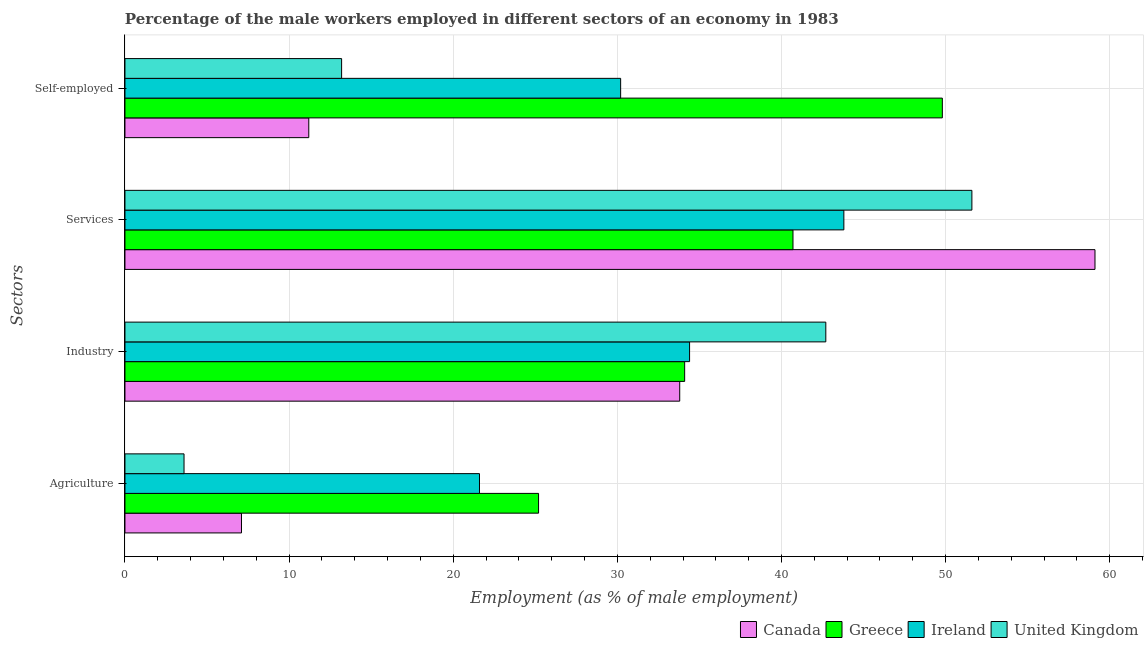How many different coloured bars are there?
Your answer should be compact. 4. Are the number of bars on each tick of the Y-axis equal?
Provide a short and direct response. Yes. How many bars are there on the 4th tick from the top?
Offer a terse response. 4. What is the label of the 4th group of bars from the top?
Your answer should be compact. Agriculture. What is the percentage of self employed male workers in United Kingdom?
Offer a very short reply. 13.2. Across all countries, what is the maximum percentage of male workers in agriculture?
Offer a very short reply. 25.2. Across all countries, what is the minimum percentage of male workers in industry?
Your response must be concise. 33.8. In which country was the percentage of male workers in services minimum?
Make the answer very short. Greece. What is the total percentage of male workers in services in the graph?
Ensure brevity in your answer.  195.2. What is the difference between the percentage of male workers in industry in Canada and that in Greece?
Your answer should be very brief. -0.3. What is the difference between the percentage of male workers in industry in Canada and the percentage of self employed male workers in Greece?
Make the answer very short. -16. What is the average percentage of self employed male workers per country?
Provide a short and direct response. 26.1. What is the difference between the percentage of male workers in services and percentage of self employed male workers in Ireland?
Make the answer very short. 13.6. In how many countries, is the percentage of male workers in industry greater than 10 %?
Make the answer very short. 4. What is the ratio of the percentage of self employed male workers in Canada to that in Greece?
Provide a succinct answer. 0.22. Is the difference between the percentage of male workers in services in Greece and United Kingdom greater than the difference between the percentage of self employed male workers in Greece and United Kingdom?
Provide a succinct answer. No. What is the difference between the highest and the lowest percentage of male workers in industry?
Your response must be concise. 8.9. What does the 2nd bar from the top in Self-employed represents?
Your answer should be very brief. Ireland. What does the 1st bar from the bottom in Industry represents?
Your answer should be very brief. Canada. Is it the case that in every country, the sum of the percentage of male workers in agriculture and percentage of male workers in industry is greater than the percentage of male workers in services?
Your response must be concise. No. Are all the bars in the graph horizontal?
Make the answer very short. Yes. How many countries are there in the graph?
Give a very brief answer. 4. Where does the legend appear in the graph?
Your answer should be compact. Bottom right. How many legend labels are there?
Provide a short and direct response. 4. How are the legend labels stacked?
Offer a terse response. Horizontal. What is the title of the graph?
Provide a short and direct response. Percentage of the male workers employed in different sectors of an economy in 1983. What is the label or title of the X-axis?
Offer a very short reply. Employment (as % of male employment). What is the label or title of the Y-axis?
Provide a short and direct response. Sectors. What is the Employment (as % of male employment) in Canada in Agriculture?
Keep it short and to the point. 7.1. What is the Employment (as % of male employment) of Greece in Agriculture?
Give a very brief answer. 25.2. What is the Employment (as % of male employment) in Ireland in Agriculture?
Provide a succinct answer. 21.6. What is the Employment (as % of male employment) of United Kingdom in Agriculture?
Your answer should be very brief. 3.6. What is the Employment (as % of male employment) of Canada in Industry?
Give a very brief answer. 33.8. What is the Employment (as % of male employment) in Greece in Industry?
Ensure brevity in your answer.  34.1. What is the Employment (as % of male employment) of Ireland in Industry?
Provide a short and direct response. 34.4. What is the Employment (as % of male employment) in United Kingdom in Industry?
Keep it short and to the point. 42.7. What is the Employment (as % of male employment) of Canada in Services?
Keep it short and to the point. 59.1. What is the Employment (as % of male employment) of Greece in Services?
Ensure brevity in your answer.  40.7. What is the Employment (as % of male employment) in Ireland in Services?
Your response must be concise. 43.8. What is the Employment (as % of male employment) in United Kingdom in Services?
Keep it short and to the point. 51.6. What is the Employment (as % of male employment) of Canada in Self-employed?
Your answer should be very brief. 11.2. What is the Employment (as % of male employment) in Greece in Self-employed?
Ensure brevity in your answer.  49.8. What is the Employment (as % of male employment) of Ireland in Self-employed?
Your answer should be compact. 30.2. What is the Employment (as % of male employment) in United Kingdom in Self-employed?
Your answer should be compact. 13.2. Across all Sectors, what is the maximum Employment (as % of male employment) of Canada?
Offer a terse response. 59.1. Across all Sectors, what is the maximum Employment (as % of male employment) in Greece?
Your answer should be compact. 49.8. Across all Sectors, what is the maximum Employment (as % of male employment) of Ireland?
Your answer should be compact. 43.8. Across all Sectors, what is the maximum Employment (as % of male employment) of United Kingdom?
Make the answer very short. 51.6. Across all Sectors, what is the minimum Employment (as % of male employment) in Canada?
Ensure brevity in your answer.  7.1. Across all Sectors, what is the minimum Employment (as % of male employment) in Greece?
Provide a short and direct response. 25.2. Across all Sectors, what is the minimum Employment (as % of male employment) in Ireland?
Your answer should be compact. 21.6. Across all Sectors, what is the minimum Employment (as % of male employment) of United Kingdom?
Provide a short and direct response. 3.6. What is the total Employment (as % of male employment) of Canada in the graph?
Offer a very short reply. 111.2. What is the total Employment (as % of male employment) in Greece in the graph?
Give a very brief answer. 149.8. What is the total Employment (as % of male employment) of Ireland in the graph?
Give a very brief answer. 130. What is the total Employment (as % of male employment) in United Kingdom in the graph?
Give a very brief answer. 111.1. What is the difference between the Employment (as % of male employment) in Canada in Agriculture and that in Industry?
Ensure brevity in your answer.  -26.7. What is the difference between the Employment (as % of male employment) of Ireland in Agriculture and that in Industry?
Your response must be concise. -12.8. What is the difference between the Employment (as % of male employment) of United Kingdom in Agriculture and that in Industry?
Make the answer very short. -39.1. What is the difference between the Employment (as % of male employment) in Canada in Agriculture and that in Services?
Give a very brief answer. -52. What is the difference between the Employment (as % of male employment) in Greece in Agriculture and that in Services?
Make the answer very short. -15.5. What is the difference between the Employment (as % of male employment) in Ireland in Agriculture and that in Services?
Ensure brevity in your answer.  -22.2. What is the difference between the Employment (as % of male employment) of United Kingdom in Agriculture and that in Services?
Provide a succinct answer. -48. What is the difference between the Employment (as % of male employment) in Greece in Agriculture and that in Self-employed?
Offer a terse response. -24.6. What is the difference between the Employment (as % of male employment) of Ireland in Agriculture and that in Self-employed?
Ensure brevity in your answer.  -8.6. What is the difference between the Employment (as % of male employment) in United Kingdom in Agriculture and that in Self-employed?
Keep it short and to the point. -9.6. What is the difference between the Employment (as % of male employment) in Canada in Industry and that in Services?
Provide a short and direct response. -25.3. What is the difference between the Employment (as % of male employment) in Ireland in Industry and that in Services?
Keep it short and to the point. -9.4. What is the difference between the Employment (as % of male employment) in United Kingdom in Industry and that in Services?
Your answer should be compact. -8.9. What is the difference between the Employment (as % of male employment) in Canada in Industry and that in Self-employed?
Your response must be concise. 22.6. What is the difference between the Employment (as % of male employment) in Greece in Industry and that in Self-employed?
Your answer should be compact. -15.7. What is the difference between the Employment (as % of male employment) in United Kingdom in Industry and that in Self-employed?
Give a very brief answer. 29.5. What is the difference between the Employment (as % of male employment) in Canada in Services and that in Self-employed?
Give a very brief answer. 47.9. What is the difference between the Employment (as % of male employment) in Ireland in Services and that in Self-employed?
Ensure brevity in your answer.  13.6. What is the difference between the Employment (as % of male employment) in United Kingdom in Services and that in Self-employed?
Offer a terse response. 38.4. What is the difference between the Employment (as % of male employment) of Canada in Agriculture and the Employment (as % of male employment) of Greece in Industry?
Your answer should be compact. -27. What is the difference between the Employment (as % of male employment) in Canada in Agriculture and the Employment (as % of male employment) in Ireland in Industry?
Keep it short and to the point. -27.3. What is the difference between the Employment (as % of male employment) in Canada in Agriculture and the Employment (as % of male employment) in United Kingdom in Industry?
Keep it short and to the point. -35.6. What is the difference between the Employment (as % of male employment) of Greece in Agriculture and the Employment (as % of male employment) of Ireland in Industry?
Make the answer very short. -9.2. What is the difference between the Employment (as % of male employment) in Greece in Agriculture and the Employment (as % of male employment) in United Kingdom in Industry?
Offer a very short reply. -17.5. What is the difference between the Employment (as % of male employment) in Ireland in Agriculture and the Employment (as % of male employment) in United Kingdom in Industry?
Provide a short and direct response. -21.1. What is the difference between the Employment (as % of male employment) in Canada in Agriculture and the Employment (as % of male employment) in Greece in Services?
Give a very brief answer. -33.6. What is the difference between the Employment (as % of male employment) of Canada in Agriculture and the Employment (as % of male employment) of Ireland in Services?
Provide a succinct answer. -36.7. What is the difference between the Employment (as % of male employment) of Canada in Agriculture and the Employment (as % of male employment) of United Kingdom in Services?
Provide a short and direct response. -44.5. What is the difference between the Employment (as % of male employment) in Greece in Agriculture and the Employment (as % of male employment) in Ireland in Services?
Provide a succinct answer. -18.6. What is the difference between the Employment (as % of male employment) in Greece in Agriculture and the Employment (as % of male employment) in United Kingdom in Services?
Ensure brevity in your answer.  -26.4. What is the difference between the Employment (as % of male employment) in Canada in Agriculture and the Employment (as % of male employment) in Greece in Self-employed?
Your response must be concise. -42.7. What is the difference between the Employment (as % of male employment) in Canada in Agriculture and the Employment (as % of male employment) in Ireland in Self-employed?
Offer a very short reply. -23.1. What is the difference between the Employment (as % of male employment) in Canada in Agriculture and the Employment (as % of male employment) in United Kingdom in Self-employed?
Your answer should be very brief. -6.1. What is the difference between the Employment (as % of male employment) of Canada in Industry and the Employment (as % of male employment) of Greece in Services?
Your answer should be very brief. -6.9. What is the difference between the Employment (as % of male employment) of Canada in Industry and the Employment (as % of male employment) of United Kingdom in Services?
Make the answer very short. -17.8. What is the difference between the Employment (as % of male employment) in Greece in Industry and the Employment (as % of male employment) in Ireland in Services?
Give a very brief answer. -9.7. What is the difference between the Employment (as % of male employment) in Greece in Industry and the Employment (as % of male employment) in United Kingdom in Services?
Ensure brevity in your answer.  -17.5. What is the difference between the Employment (as % of male employment) of Ireland in Industry and the Employment (as % of male employment) of United Kingdom in Services?
Offer a very short reply. -17.2. What is the difference between the Employment (as % of male employment) of Canada in Industry and the Employment (as % of male employment) of United Kingdom in Self-employed?
Make the answer very short. 20.6. What is the difference between the Employment (as % of male employment) in Greece in Industry and the Employment (as % of male employment) in Ireland in Self-employed?
Provide a short and direct response. 3.9. What is the difference between the Employment (as % of male employment) in Greece in Industry and the Employment (as % of male employment) in United Kingdom in Self-employed?
Keep it short and to the point. 20.9. What is the difference between the Employment (as % of male employment) in Ireland in Industry and the Employment (as % of male employment) in United Kingdom in Self-employed?
Provide a short and direct response. 21.2. What is the difference between the Employment (as % of male employment) in Canada in Services and the Employment (as % of male employment) in Ireland in Self-employed?
Provide a succinct answer. 28.9. What is the difference between the Employment (as % of male employment) in Canada in Services and the Employment (as % of male employment) in United Kingdom in Self-employed?
Ensure brevity in your answer.  45.9. What is the difference between the Employment (as % of male employment) of Greece in Services and the Employment (as % of male employment) of Ireland in Self-employed?
Your response must be concise. 10.5. What is the difference between the Employment (as % of male employment) in Ireland in Services and the Employment (as % of male employment) in United Kingdom in Self-employed?
Ensure brevity in your answer.  30.6. What is the average Employment (as % of male employment) in Canada per Sectors?
Provide a short and direct response. 27.8. What is the average Employment (as % of male employment) in Greece per Sectors?
Your answer should be compact. 37.45. What is the average Employment (as % of male employment) in Ireland per Sectors?
Provide a succinct answer. 32.5. What is the average Employment (as % of male employment) in United Kingdom per Sectors?
Your response must be concise. 27.77. What is the difference between the Employment (as % of male employment) in Canada and Employment (as % of male employment) in Greece in Agriculture?
Keep it short and to the point. -18.1. What is the difference between the Employment (as % of male employment) in Canada and Employment (as % of male employment) in Ireland in Agriculture?
Provide a succinct answer. -14.5. What is the difference between the Employment (as % of male employment) in Greece and Employment (as % of male employment) in United Kingdom in Agriculture?
Give a very brief answer. 21.6. What is the difference between the Employment (as % of male employment) in Canada and Employment (as % of male employment) in Greece in Industry?
Provide a succinct answer. -0.3. What is the difference between the Employment (as % of male employment) of Canada and Employment (as % of male employment) of United Kingdom in Industry?
Offer a very short reply. -8.9. What is the difference between the Employment (as % of male employment) of Greece and Employment (as % of male employment) of United Kingdom in Industry?
Your response must be concise. -8.6. What is the difference between the Employment (as % of male employment) of Canada and Employment (as % of male employment) of United Kingdom in Services?
Your answer should be compact. 7.5. What is the difference between the Employment (as % of male employment) in Greece and Employment (as % of male employment) in Ireland in Services?
Provide a short and direct response. -3.1. What is the difference between the Employment (as % of male employment) in Canada and Employment (as % of male employment) in Greece in Self-employed?
Your answer should be very brief. -38.6. What is the difference between the Employment (as % of male employment) of Canada and Employment (as % of male employment) of Ireland in Self-employed?
Ensure brevity in your answer.  -19. What is the difference between the Employment (as % of male employment) in Canada and Employment (as % of male employment) in United Kingdom in Self-employed?
Give a very brief answer. -2. What is the difference between the Employment (as % of male employment) in Greece and Employment (as % of male employment) in Ireland in Self-employed?
Ensure brevity in your answer.  19.6. What is the difference between the Employment (as % of male employment) in Greece and Employment (as % of male employment) in United Kingdom in Self-employed?
Provide a succinct answer. 36.6. What is the ratio of the Employment (as % of male employment) of Canada in Agriculture to that in Industry?
Give a very brief answer. 0.21. What is the ratio of the Employment (as % of male employment) of Greece in Agriculture to that in Industry?
Ensure brevity in your answer.  0.74. What is the ratio of the Employment (as % of male employment) of Ireland in Agriculture to that in Industry?
Ensure brevity in your answer.  0.63. What is the ratio of the Employment (as % of male employment) of United Kingdom in Agriculture to that in Industry?
Give a very brief answer. 0.08. What is the ratio of the Employment (as % of male employment) in Canada in Agriculture to that in Services?
Your answer should be compact. 0.12. What is the ratio of the Employment (as % of male employment) in Greece in Agriculture to that in Services?
Offer a terse response. 0.62. What is the ratio of the Employment (as % of male employment) of Ireland in Agriculture to that in Services?
Your answer should be compact. 0.49. What is the ratio of the Employment (as % of male employment) of United Kingdom in Agriculture to that in Services?
Your response must be concise. 0.07. What is the ratio of the Employment (as % of male employment) of Canada in Agriculture to that in Self-employed?
Offer a terse response. 0.63. What is the ratio of the Employment (as % of male employment) of Greece in Agriculture to that in Self-employed?
Give a very brief answer. 0.51. What is the ratio of the Employment (as % of male employment) of Ireland in Agriculture to that in Self-employed?
Your answer should be compact. 0.72. What is the ratio of the Employment (as % of male employment) of United Kingdom in Agriculture to that in Self-employed?
Offer a very short reply. 0.27. What is the ratio of the Employment (as % of male employment) in Canada in Industry to that in Services?
Your answer should be compact. 0.57. What is the ratio of the Employment (as % of male employment) in Greece in Industry to that in Services?
Your answer should be compact. 0.84. What is the ratio of the Employment (as % of male employment) in Ireland in Industry to that in Services?
Keep it short and to the point. 0.79. What is the ratio of the Employment (as % of male employment) of United Kingdom in Industry to that in Services?
Provide a short and direct response. 0.83. What is the ratio of the Employment (as % of male employment) of Canada in Industry to that in Self-employed?
Ensure brevity in your answer.  3.02. What is the ratio of the Employment (as % of male employment) in Greece in Industry to that in Self-employed?
Keep it short and to the point. 0.68. What is the ratio of the Employment (as % of male employment) in Ireland in Industry to that in Self-employed?
Keep it short and to the point. 1.14. What is the ratio of the Employment (as % of male employment) in United Kingdom in Industry to that in Self-employed?
Make the answer very short. 3.23. What is the ratio of the Employment (as % of male employment) of Canada in Services to that in Self-employed?
Your answer should be very brief. 5.28. What is the ratio of the Employment (as % of male employment) in Greece in Services to that in Self-employed?
Keep it short and to the point. 0.82. What is the ratio of the Employment (as % of male employment) in Ireland in Services to that in Self-employed?
Provide a succinct answer. 1.45. What is the ratio of the Employment (as % of male employment) of United Kingdom in Services to that in Self-employed?
Keep it short and to the point. 3.91. What is the difference between the highest and the second highest Employment (as % of male employment) of Canada?
Offer a very short reply. 25.3. What is the difference between the highest and the second highest Employment (as % of male employment) of Ireland?
Offer a very short reply. 9.4. What is the difference between the highest and the second highest Employment (as % of male employment) in United Kingdom?
Your response must be concise. 8.9. What is the difference between the highest and the lowest Employment (as % of male employment) in Greece?
Your response must be concise. 24.6. What is the difference between the highest and the lowest Employment (as % of male employment) in Ireland?
Ensure brevity in your answer.  22.2. 